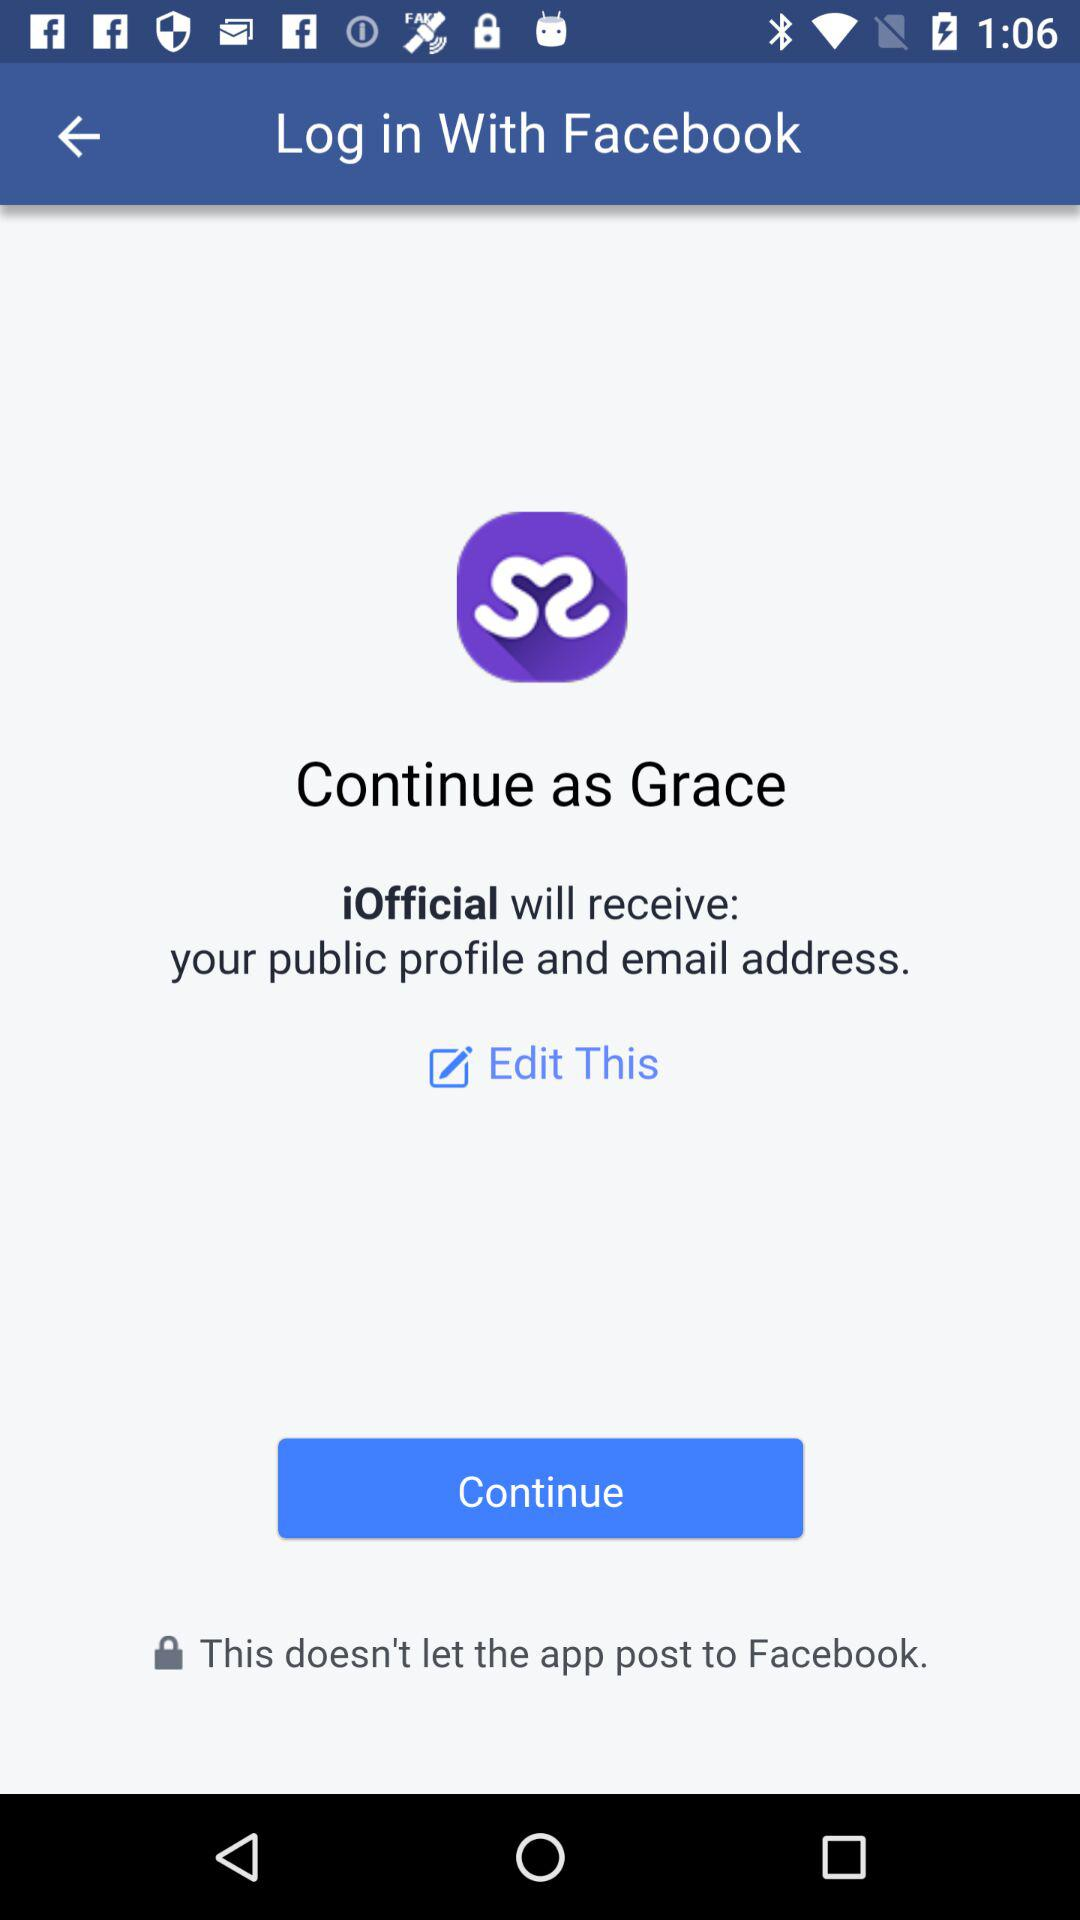Which application will receive the public profile and email address? The application is "iOfficial". 